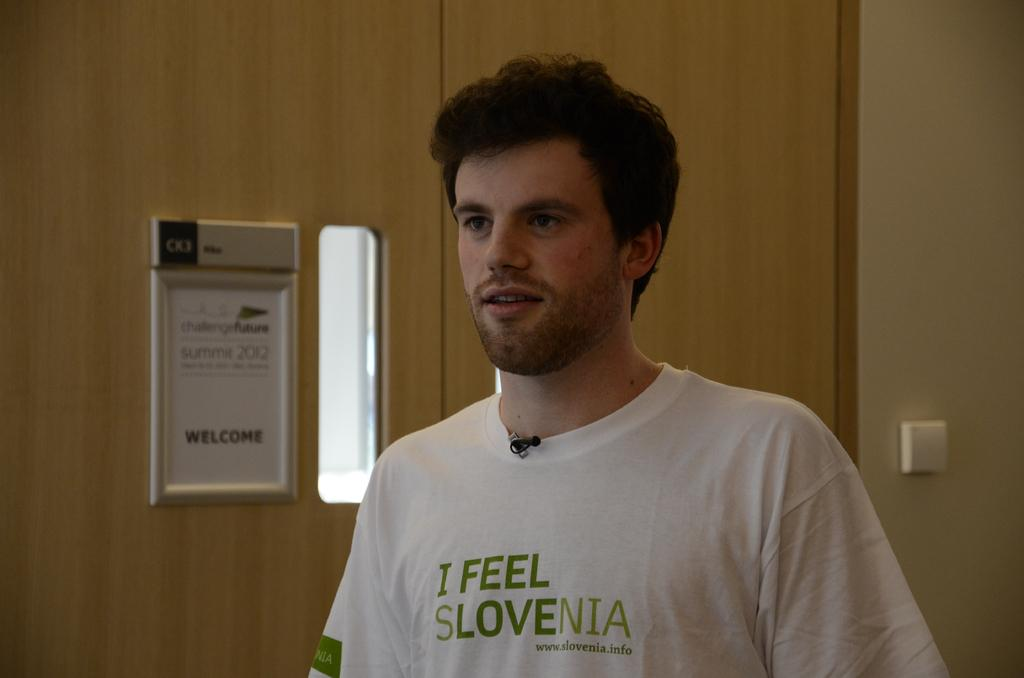Who or what is the main subject in the center of the image? There is a person in the center of the image. What can be seen in the background of the image? There is a door, a board, and a wall in the background of the image. What is written or depicted on the board? There is text on the board. How does the person in the image maintain their balance on the square object? There is no square object present in the image, and the person is not shown balancing on anything. 